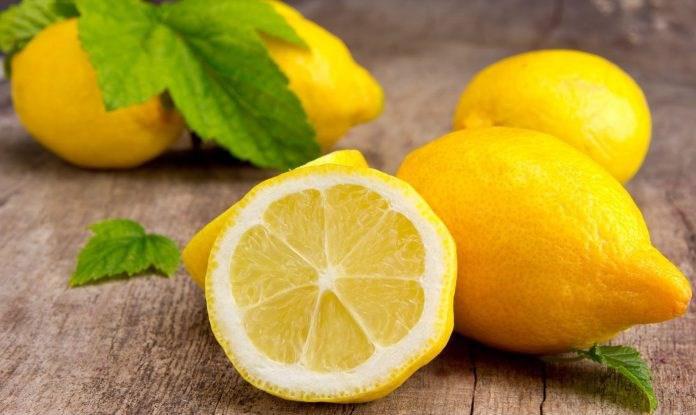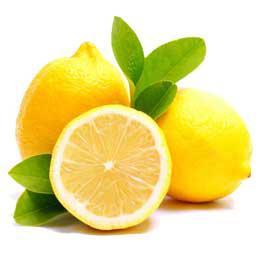The first image is the image on the left, the second image is the image on the right. Considering the images on both sides, is "A single half of a lemon sits with some whole lemons in each of the images." valid? Answer yes or no. Yes. The first image is the image on the left, the second image is the image on the right. Evaluate the accuracy of this statement regarding the images: "The lemons are still hanging from the tree in one picture.". Is it true? Answer yes or no. No. 